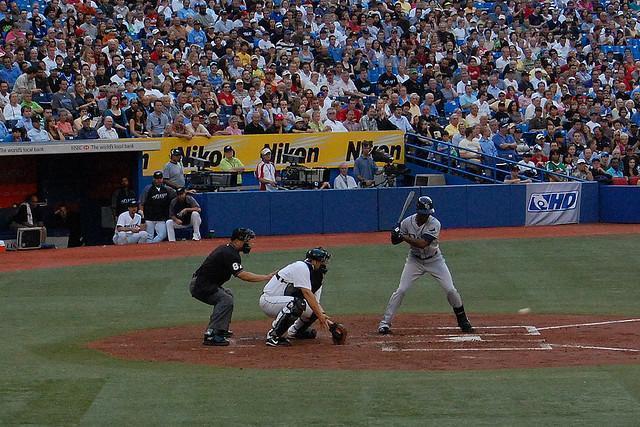What kind of product does the sponsor with the yellow background offer?
From the following set of four choices, select the accurate answer to respond to the question.
Options: Phones, computers, musical instruments, cameras. Cameras. 